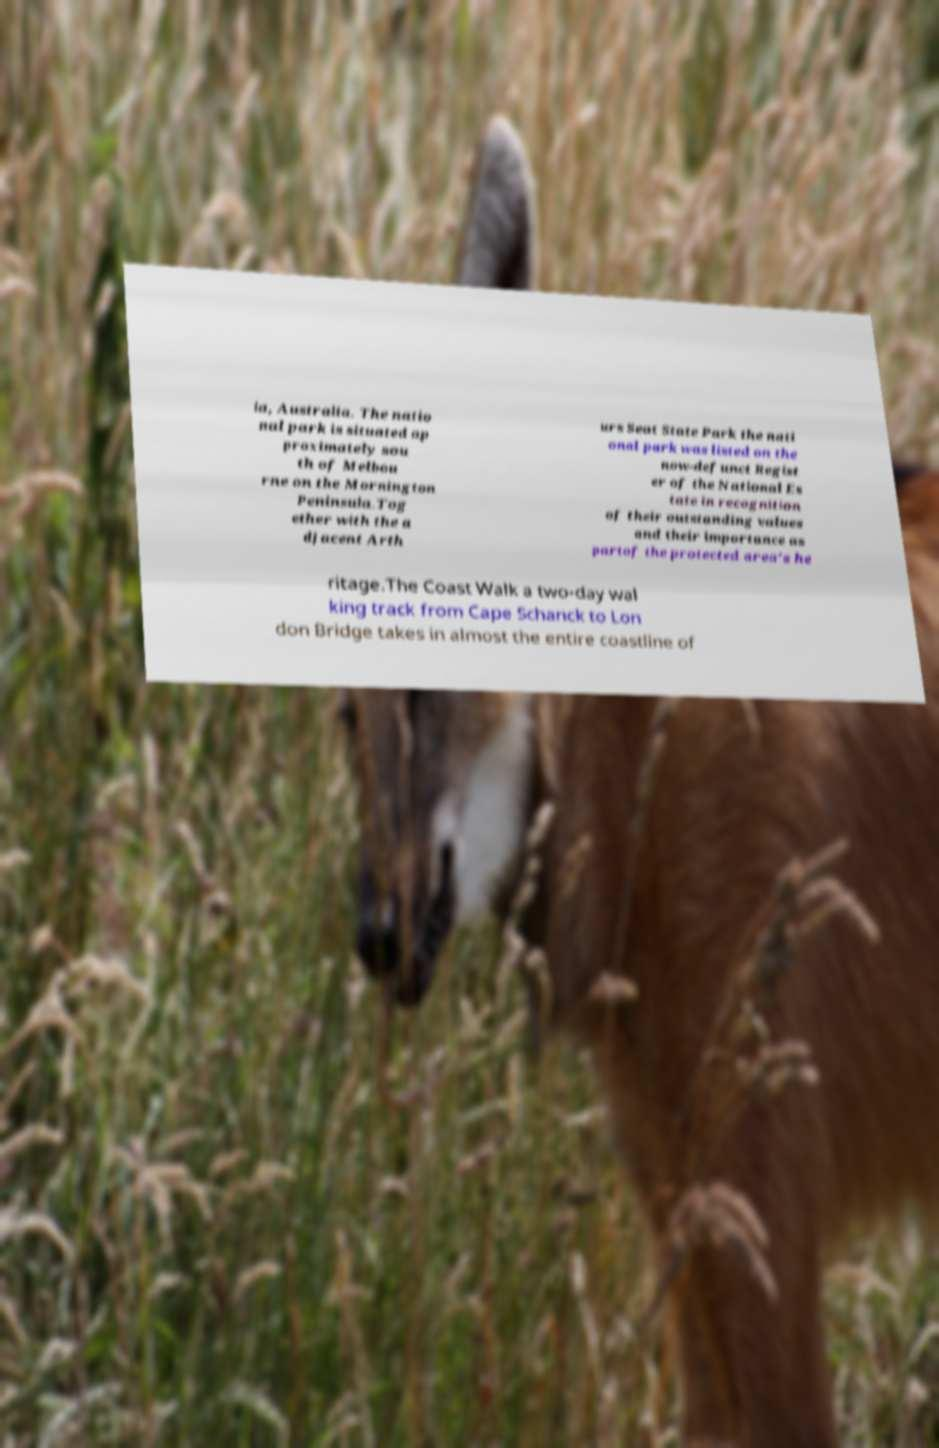For documentation purposes, I need the text within this image transcribed. Could you provide that? ia, Australia. The natio nal park is situated ap proximately sou th of Melbou rne on the Mornington Peninsula.Tog ether with the a djacent Arth urs Seat State Park the nati onal park was listed on the now-defunct Regist er of the National Es tate in recognition of their outstanding values and their importance as partof the protected area's he ritage.The Coast Walk a two-day wal king track from Cape Schanck to Lon don Bridge takes in almost the entire coastline of 